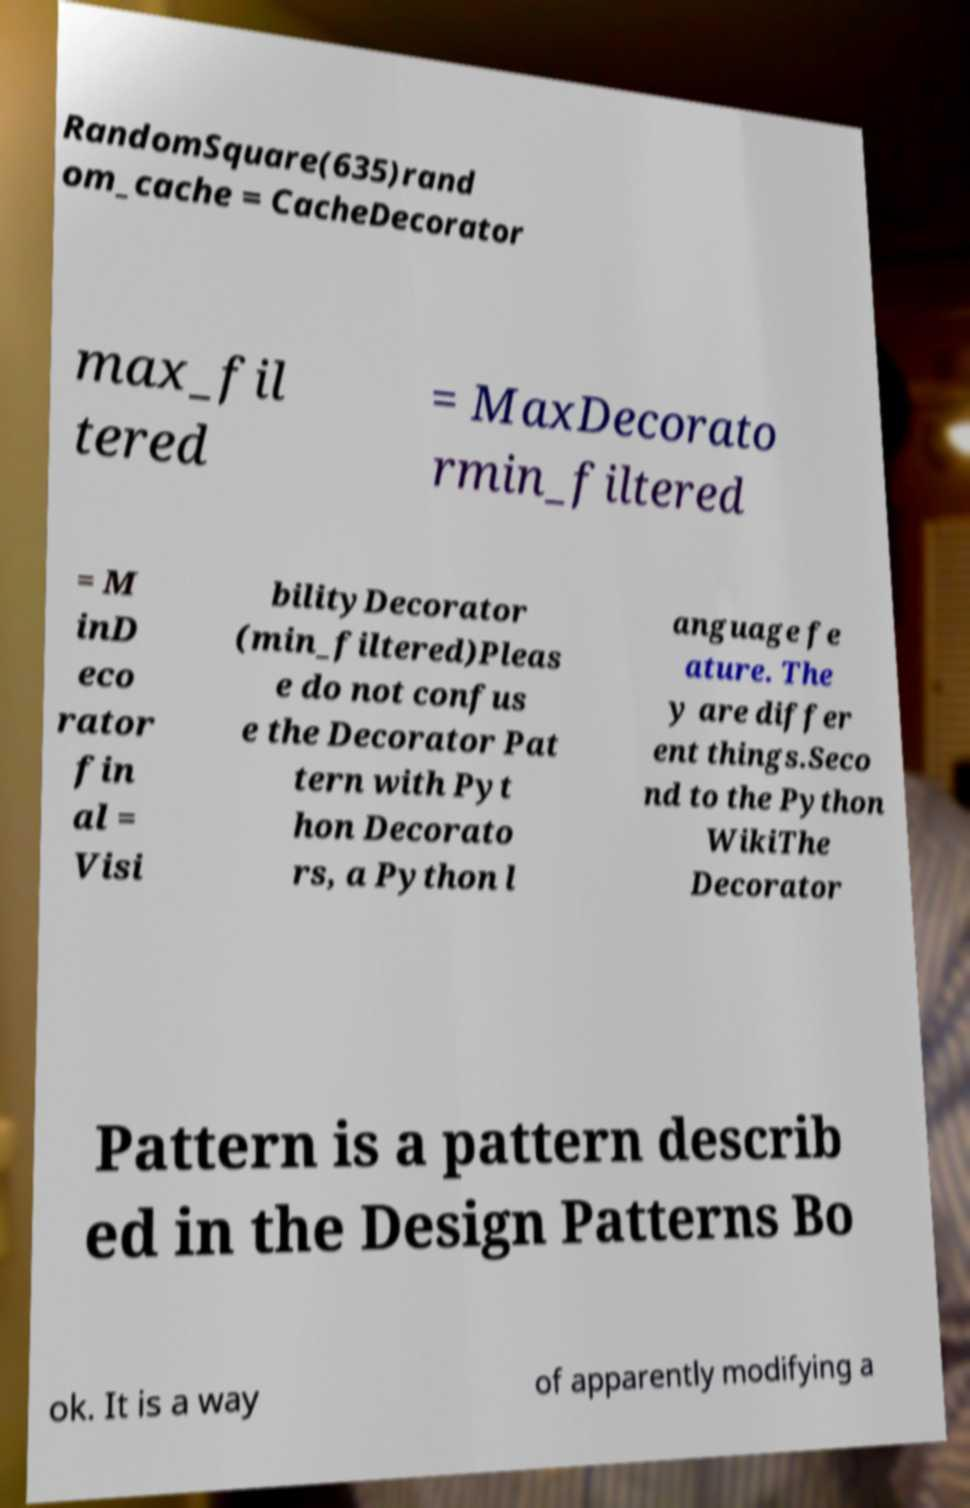Can you read and provide the text displayed in the image?This photo seems to have some interesting text. Can you extract and type it out for me? RandomSquare(635)rand om_cache = CacheDecorator max_fil tered = MaxDecorato rmin_filtered = M inD eco rator fin al = Visi bilityDecorator (min_filtered)Pleas e do not confus e the Decorator Pat tern with Pyt hon Decorato rs, a Python l anguage fe ature. The y are differ ent things.Seco nd to the Python WikiThe Decorator Pattern is a pattern describ ed in the Design Patterns Bo ok. It is a way of apparently modifying a 